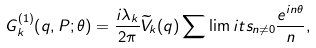Convert formula to latex. <formula><loc_0><loc_0><loc_500><loc_500>G _ { k } ^ { ( 1 ) } { \left ( q , P ; \theta \right ) } = { \frac { i \lambda _ { k } } { 2 \pi } } { \widetilde { V } } _ { k } ( q ) \sum \lim i t s _ { n \neq 0 } { \frac { e ^ { i n \theta } } { n } } ,</formula> 